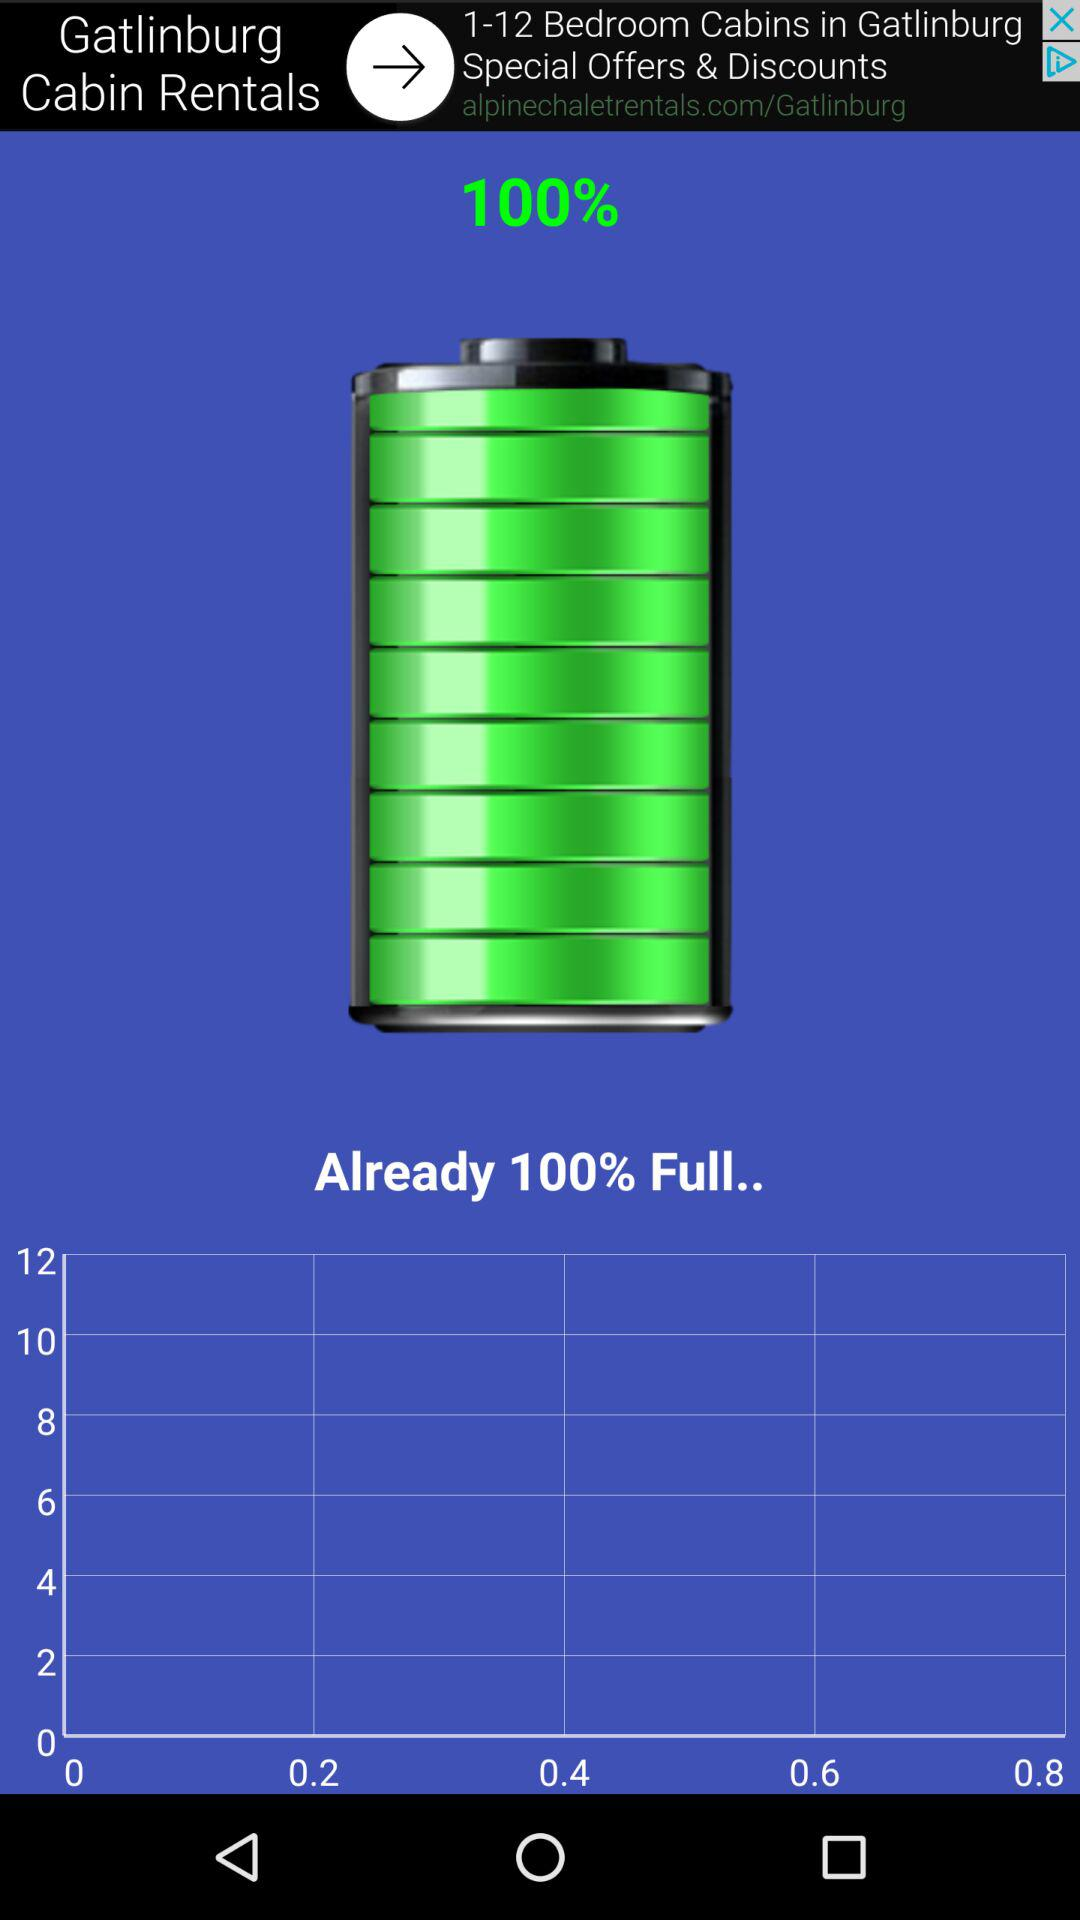What's the percentage of the battery? The battery percentage is 100. 